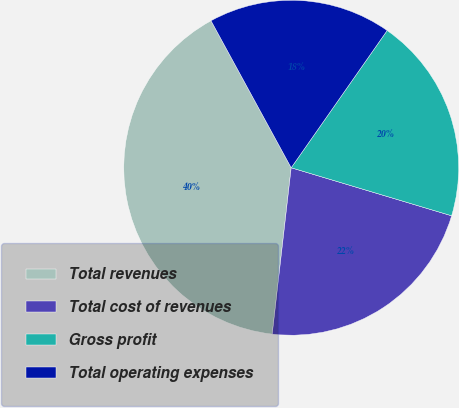Convert chart. <chart><loc_0><loc_0><loc_500><loc_500><pie_chart><fcel>Total revenues<fcel>Total cost of revenues<fcel>Gross profit<fcel>Total operating expenses<nl><fcel>40.25%<fcel>22.18%<fcel>19.92%<fcel>17.66%<nl></chart> 